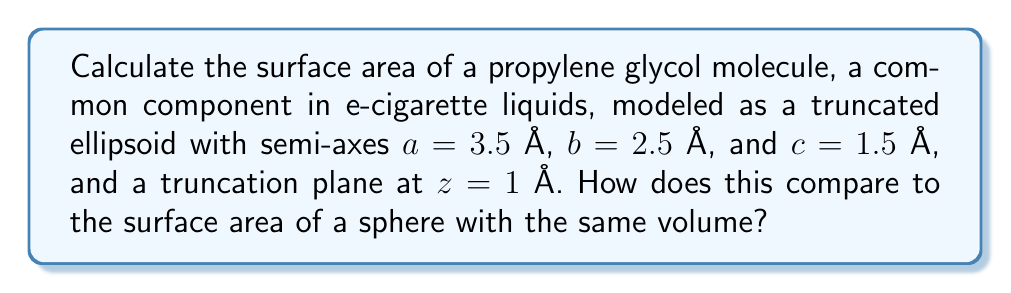What is the answer to this math problem? 1. The surface area of a truncated ellipsoid can be approximated using the following formula:

   $$S \approx 2\pi ab \left(\frac{1 + \frac{c}{e}\arcsin(e)}{1 + \frac{c}{a}}\right) + \pi\frac{a^2b^2}{c}\left(1 - \frac{z^2}{c^2}\right)$$

   where $e = \sqrt{1 - \frac{b^2}{a^2}}$ is the eccentricity.

2. Calculate the eccentricity:
   $$e = \sqrt{1 - \frac{2.5^2}{3.5^2}} \approx 0.7071$$

3. Substitute the values into the surface area formula:
   $$S \approx 2\pi(3.5)(2.5) \left(\frac{1 + \frac{1.5}{0.7071}\arcsin(0.7071)}{1 + \frac{1.5}{3.5}}\right) + \pi\frac{3.5^2 \cdot 2.5^2}{1.5}\left(1 - \frac{1^2}{1.5^2}\right)$$

4. Evaluate:
   $$S \approx 74.6 \text{ Å}^2$$

5. To compare with a sphere, first calculate the volume of the truncated ellipsoid:
   $$V = \frac{4}{3}\pi abc \left(1 - \frac{z}{c}\right) \approx 33.5 \text{ Å}^3$$

6. Find the radius of a sphere with the same volume:
   $$r = \sqrt[3]{\frac{3V}{4\pi}} \approx 2.01 \text{ Å}$$

7. Calculate the surface area of this sphere:
   $$S_{sphere} = 4\pi r^2 \approx 50.8 \text{ Å}^2$$

8. Compare the two surface areas:
   The truncated ellipsoid has approximately 46.8% more surface area than a sphere of equal volume.
Answer: $74.6 \text{ Å}^2$; 46.8% larger than equivalent sphere 